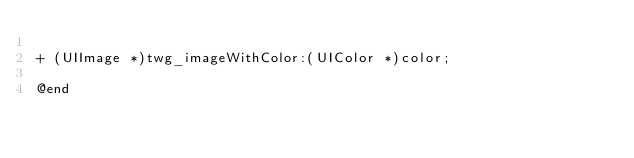Convert code to text. <code><loc_0><loc_0><loc_500><loc_500><_C_>
+ (UIImage *)twg_imageWithColor:(UIColor *)color;

@end
</code> 